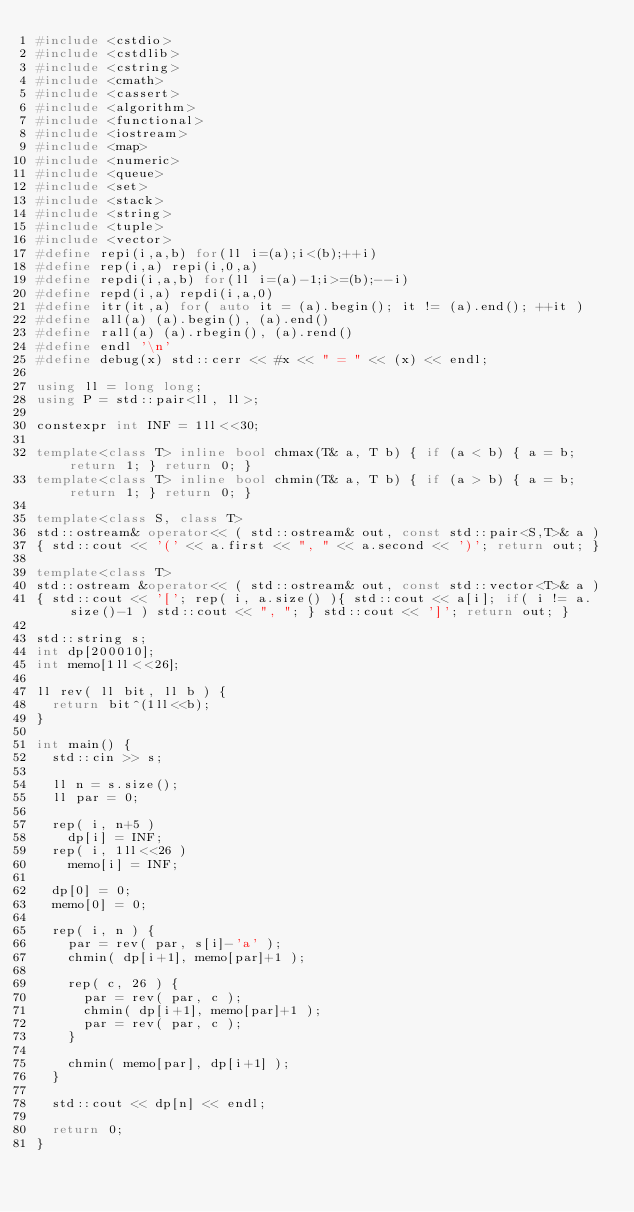Convert code to text. <code><loc_0><loc_0><loc_500><loc_500><_C++_>#include <cstdio>
#include <cstdlib>
#include <cstring>
#include <cmath>
#include <cassert>
#include <algorithm>
#include <functional>
#include <iostream>
#include <map>
#include <numeric>
#include <queue>
#include <set>
#include <stack>
#include <string>
#include <tuple>
#include <vector>
#define repi(i,a,b) for(ll i=(a);i<(b);++i)
#define rep(i,a) repi(i,0,a)
#define repdi(i,a,b) for(ll i=(a)-1;i>=(b);--i)
#define repd(i,a) repdi(i,a,0)
#define itr(it,a) for( auto it = (a).begin(); it != (a).end(); ++it )
#define all(a) (a).begin(), (a).end()
#define rall(a) (a).rbegin(), (a).rend()
#define endl '\n'
#define debug(x) std::cerr << #x << " = " << (x) << endl;

using ll = long long;
using P = std::pair<ll, ll>;

constexpr int INF = 1ll<<30;

template<class T> inline bool chmax(T& a, T b) { if (a < b) { a = b; return 1; } return 0; }
template<class T> inline bool chmin(T& a, T b) { if (a > b) { a = b; return 1; } return 0; }

template<class S, class T>
std::ostream& operator<< ( std::ostream& out, const std::pair<S,T>& a )
{ std::cout << '(' << a.first << ", " << a.second << ')'; return out; }

template<class T>
std::ostream &operator<< ( std::ostream& out, const std::vector<T>& a )
{ std::cout << '['; rep( i, a.size() ){ std::cout << a[i]; if( i != a.size()-1 ) std::cout << ", "; } std::cout << ']'; return out; }

std::string s;
int dp[200010];
int memo[1ll<<26];

ll rev( ll bit, ll b ) {
  return bit^(1ll<<b);
}

int main() {
  std::cin >> s;

  ll n = s.size();
  ll par = 0;

  rep( i, n+5 )
    dp[i] = INF;
  rep( i, 1ll<<26 )
    memo[i] = INF;

  dp[0] = 0;
  memo[0] = 0;

  rep( i, n ) {
    par = rev( par, s[i]-'a' );
    chmin( dp[i+1], memo[par]+1 );
    
    rep( c, 26 ) {
      par = rev( par, c );
      chmin( dp[i+1], memo[par]+1 );
      par = rev( par, c );
    }

    chmin( memo[par], dp[i+1] );
  }

  std::cout << dp[n] << endl;

  return 0;
}</code> 